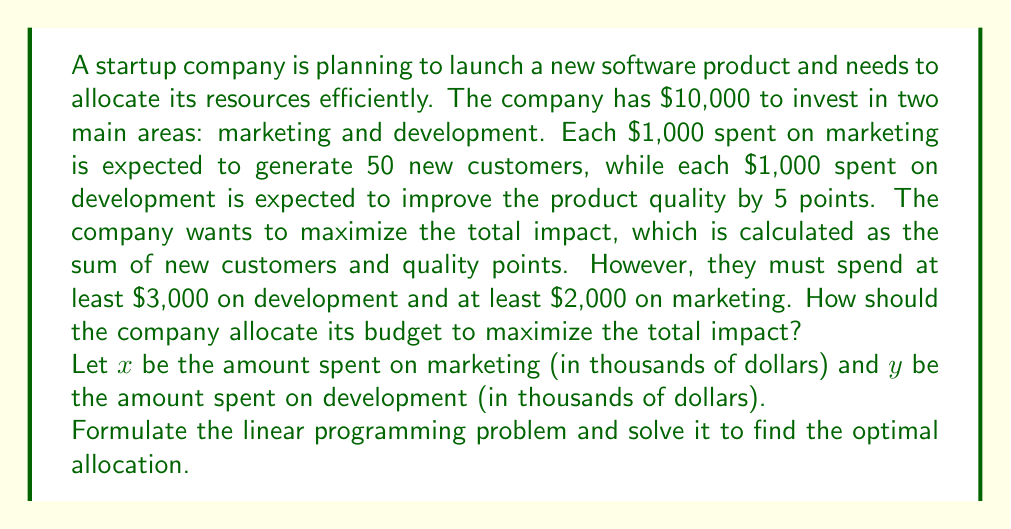Can you answer this question? To solve this linear programming problem, we'll follow these steps:

1. Define the objective function
2. Identify the constraints
3. Set up the linear programming problem
4. Solve using the graphical method

Step 1: Define the objective function

The total impact is the sum of new customers and quality points:
- Marketing: $50x$ new customers
- Development: $5y$ quality points

Objective function: Maximize $Z = 50x + 5y$

Step 2: Identify the constraints

- Total budget: $x + y \leq 10$
- Minimum marketing spend: $x \geq 2$
- Minimum development spend: $y \geq 3$
- Non-negativity: $x \geq 0, y \geq 0$

Step 3: Set up the linear programming problem

Maximize $Z = 50x + 5y$
Subject to:
$$\begin{align*}
x + y &\leq 10 \\
x &\geq 2 \\
y &\geq 3 \\
x, y &\geq 0
\end{align*}$$

Step 4: Solve using the graphical method

1. Plot the constraints:
   - $x + y = 10$ (budget line)
   - $x = 2$ (minimum marketing)
   - $y = 3$ (minimum development)

2. Identify the feasible region (the area that satisfies all constraints).

3. Find the corner points of the feasible region:
   A (2, 3), B (2, 8), C (7, 3)

4. Evaluate the objective function at each corner point:
   - A: $Z = 50(2) + 5(3) = 115$
   - B: $Z = 50(2) + 5(8) = 140$
   - C: $Z = 50(7) + 5(3) = 365$

The maximum value occurs at point C (7, 3), which represents $7,000 spent on marketing and $3,000 spent on development.
Answer: The optimal allocation is to spend $7,000 on marketing and $3,000 on development, resulting in a maximum total impact of 365 (350 new customers + 15 quality points). 